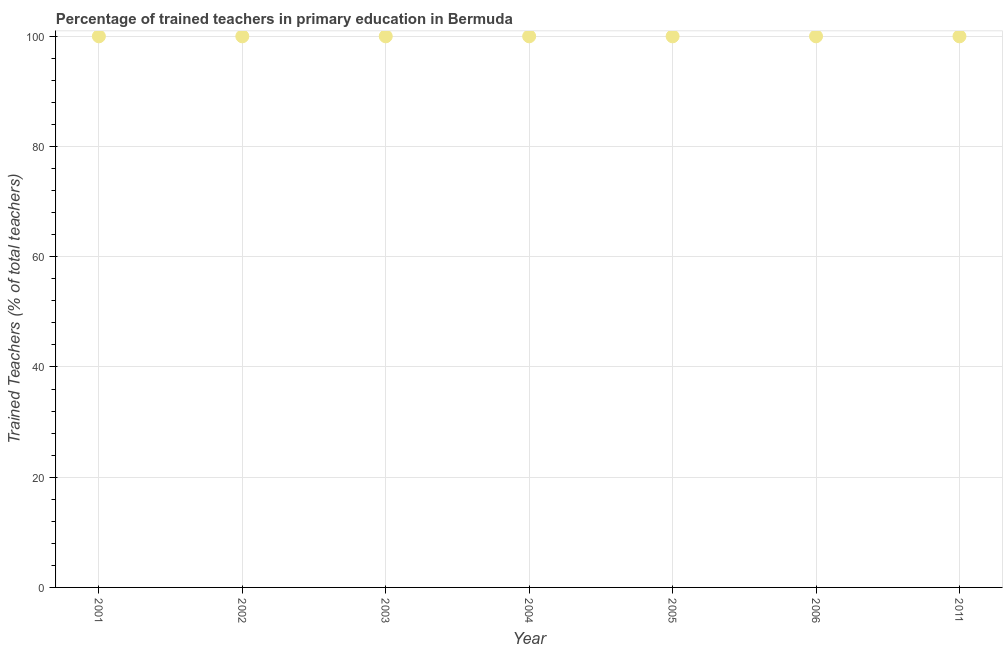What is the percentage of trained teachers in 2003?
Your response must be concise. 100. In which year was the percentage of trained teachers maximum?
Your response must be concise. 2001. What is the sum of the percentage of trained teachers?
Ensure brevity in your answer.  700. What is the difference between the percentage of trained teachers in 2005 and 2011?
Make the answer very short. 0. In how many years, is the percentage of trained teachers greater than 20 %?
Provide a short and direct response. 7. Do a majority of the years between 2001 and 2002 (inclusive) have percentage of trained teachers greater than 68 %?
Make the answer very short. Yes. What is the ratio of the percentage of trained teachers in 2002 to that in 2011?
Give a very brief answer. 1. Is the percentage of trained teachers in 2001 less than that in 2002?
Offer a terse response. No. Is the difference between the percentage of trained teachers in 2002 and 2006 greater than the difference between any two years?
Provide a short and direct response. Yes. Does the graph contain any zero values?
Provide a succinct answer. No. What is the title of the graph?
Give a very brief answer. Percentage of trained teachers in primary education in Bermuda. What is the label or title of the Y-axis?
Make the answer very short. Trained Teachers (% of total teachers). What is the Trained Teachers (% of total teachers) in 2002?
Offer a terse response. 100. What is the Trained Teachers (% of total teachers) in 2003?
Ensure brevity in your answer.  100. What is the Trained Teachers (% of total teachers) in 2005?
Your answer should be very brief. 100. What is the Trained Teachers (% of total teachers) in 2006?
Your response must be concise. 100. What is the difference between the Trained Teachers (% of total teachers) in 2001 and 2002?
Provide a short and direct response. 0. What is the difference between the Trained Teachers (% of total teachers) in 2001 and 2011?
Ensure brevity in your answer.  0. What is the difference between the Trained Teachers (% of total teachers) in 2002 and 2003?
Offer a terse response. 0. What is the difference between the Trained Teachers (% of total teachers) in 2002 and 2005?
Your answer should be very brief. 0. What is the difference between the Trained Teachers (% of total teachers) in 2002 and 2011?
Your answer should be very brief. 0. What is the difference between the Trained Teachers (% of total teachers) in 2003 and 2005?
Keep it short and to the point. 0. What is the difference between the Trained Teachers (% of total teachers) in 2004 and 2005?
Provide a succinct answer. 0. What is the difference between the Trained Teachers (% of total teachers) in 2005 and 2006?
Give a very brief answer. 0. What is the difference between the Trained Teachers (% of total teachers) in 2006 and 2011?
Make the answer very short. 0. What is the ratio of the Trained Teachers (% of total teachers) in 2001 to that in 2002?
Offer a terse response. 1. What is the ratio of the Trained Teachers (% of total teachers) in 2001 to that in 2003?
Make the answer very short. 1. What is the ratio of the Trained Teachers (% of total teachers) in 2001 to that in 2004?
Offer a terse response. 1. What is the ratio of the Trained Teachers (% of total teachers) in 2001 to that in 2006?
Your answer should be very brief. 1. What is the ratio of the Trained Teachers (% of total teachers) in 2001 to that in 2011?
Offer a terse response. 1. What is the ratio of the Trained Teachers (% of total teachers) in 2002 to that in 2004?
Ensure brevity in your answer.  1. What is the ratio of the Trained Teachers (% of total teachers) in 2002 to that in 2005?
Your response must be concise. 1. What is the ratio of the Trained Teachers (% of total teachers) in 2002 to that in 2006?
Make the answer very short. 1. What is the ratio of the Trained Teachers (% of total teachers) in 2002 to that in 2011?
Make the answer very short. 1. What is the ratio of the Trained Teachers (% of total teachers) in 2003 to that in 2006?
Ensure brevity in your answer.  1. What is the ratio of the Trained Teachers (% of total teachers) in 2003 to that in 2011?
Your answer should be compact. 1. What is the ratio of the Trained Teachers (% of total teachers) in 2004 to that in 2005?
Ensure brevity in your answer.  1. What is the ratio of the Trained Teachers (% of total teachers) in 2004 to that in 2006?
Provide a succinct answer. 1. What is the ratio of the Trained Teachers (% of total teachers) in 2005 to that in 2006?
Your answer should be compact. 1. What is the ratio of the Trained Teachers (% of total teachers) in 2005 to that in 2011?
Offer a terse response. 1. 